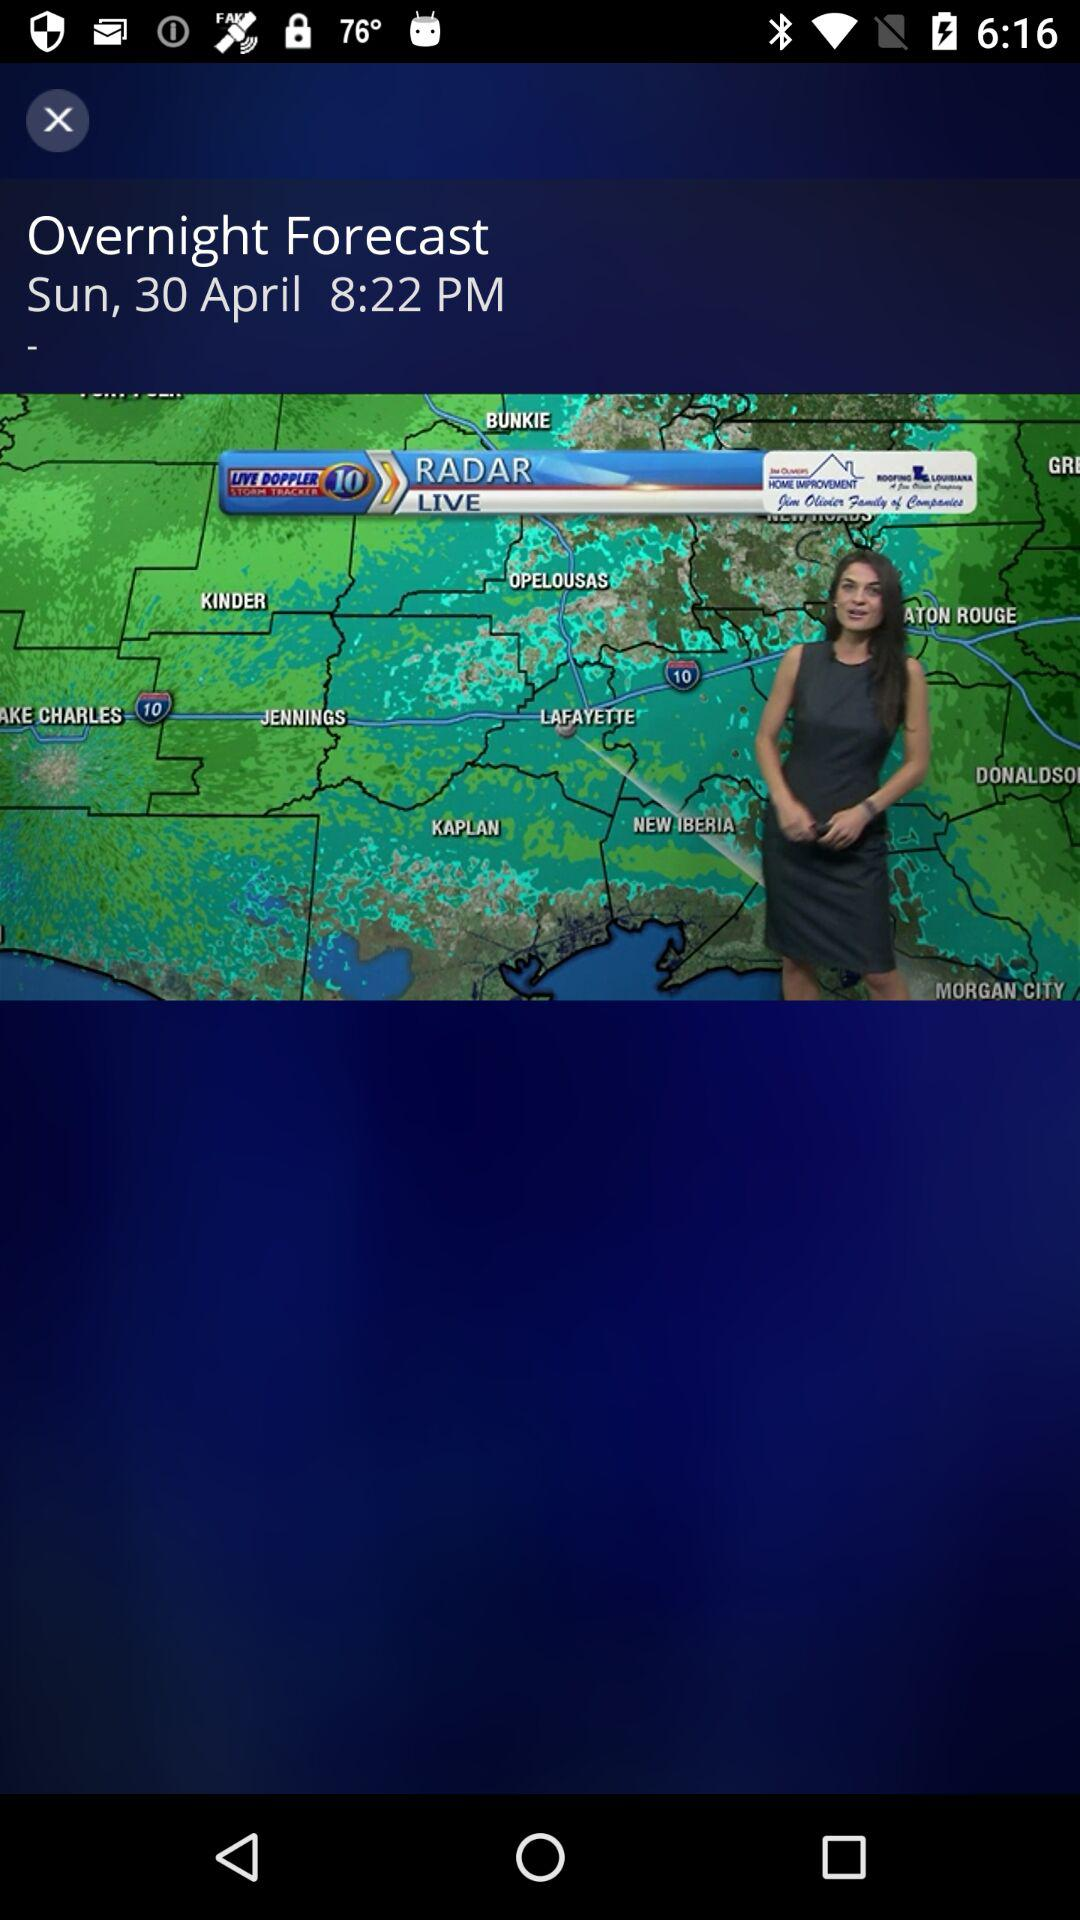On which day will the overnight forecast air? The overnight forecast will air on Sunday. 